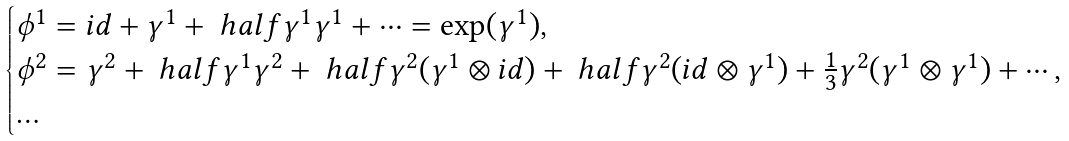<formula> <loc_0><loc_0><loc_500><loc_500>\begin{cases} \phi ^ { 1 } = i d + \gamma ^ { 1 } + \ h a l f \gamma ^ { 1 } \gamma ^ { 1 } + \cdots = \exp ( \gamma ^ { 1 } ) , \\ \phi ^ { 2 } = \gamma ^ { 2 } + \ h a l f \gamma ^ { 1 } \gamma ^ { 2 } + \ h a l f \gamma ^ { 2 } ( \gamma ^ { 1 } \otimes i d ) + \ h a l f \gamma ^ { 2 } ( i d \otimes \gamma ^ { 1 } ) + \frac { 1 } { 3 } \gamma ^ { 2 } ( \gamma ^ { 1 } \otimes \gamma ^ { 1 } ) + \cdots , \\ \dots \end{cases}</formula> 